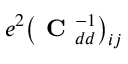Convert formula to latex. <formula><loc_0><loc_0><loc_500><loc_500>e ^ { 2 } \left ( C _ { d d } ^ { - 1 } \right ) _ { i j }</formula> 